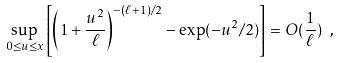<formula> <loc_0><loc_0><loc_500><loc_500>\sup _ { 0 \leq u \leq x } \left [ \left ( 1 + \frac { u ^ { 2 } } { \ell } \right ) ^ { - ( \ell + 1 ) / 2 } - \exp ( - u ^ { 2 } / 2 ) \right ] = O ( \frac { 1 } { \ell } ) \text { } ,</formula> 